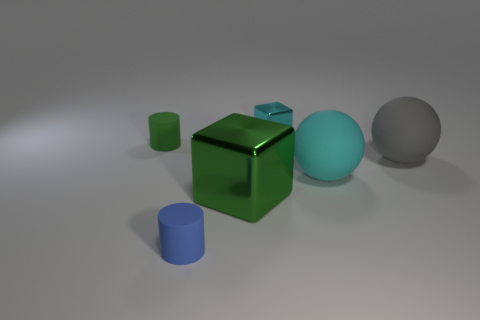Is the number of large gray things left of the green cube less than the number of big green blocks behind the tiny shiny thing?
Keep it short and to the point. No. What number of other things are the same size as the gray sphere?
Provide a short and direct response. 2. Are the blue thing and the large thing behind the large cyan rubber object made of the same material?
Offer a very short reply. Yes. How many objects are matte things that are to the right of the large block or cylinders in front of the large green thing?
Your response must be concise. 3. The big metal thing has what color?
Provide a short and direct response. Green. Are there fewer green matte cylinders that are behind the big gray thing than green cubes?
Offer a terse response. No. Are there any other things that are the same shape as the gray object?
Your answer should be compact. Yes. Are there any large gray spheres?
Your response must be concise. Yes. Are there fewer large matte things than blue cylinders?
Provide a short and direct response. No. What number of blocks are made of the same material as the tiny green thing?
Provide a short and direct response. 0. 